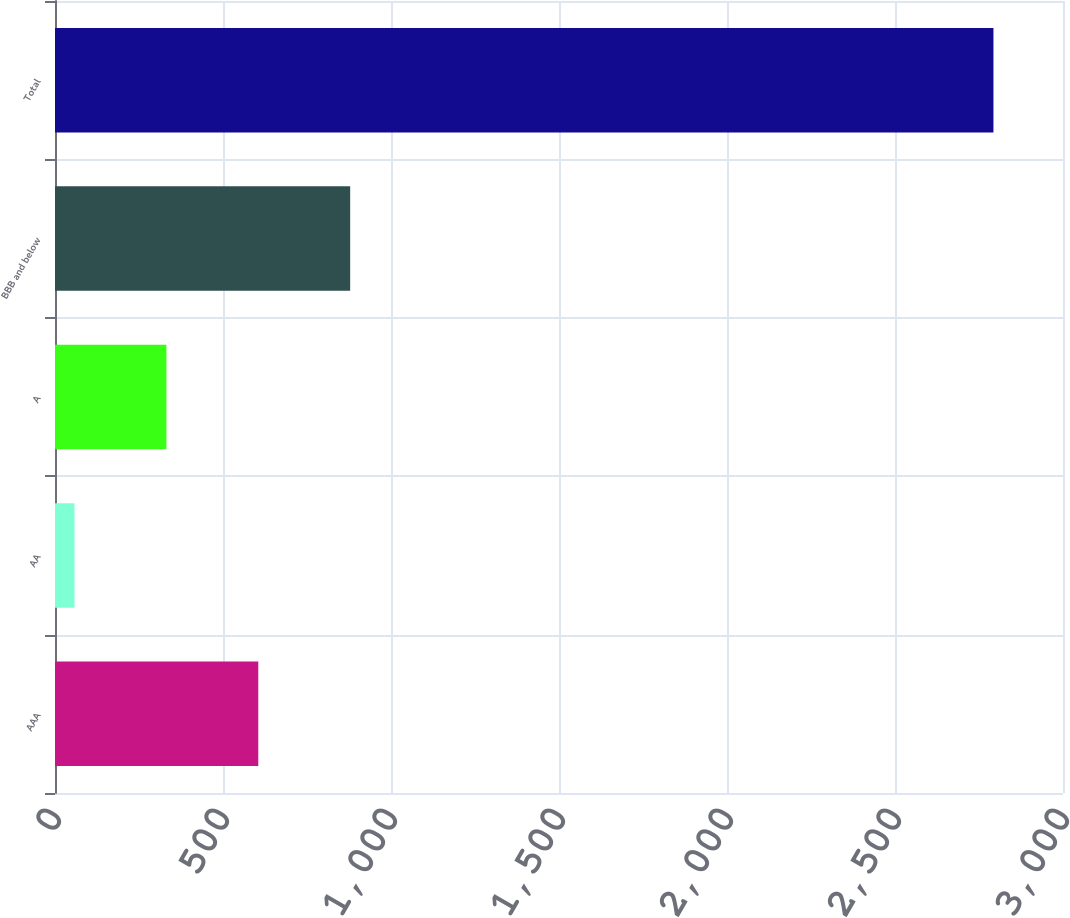Convert chart to OTSL. <chart><loc_0><loc_0><loc_500><loc_500><bar_chart><fcel>AAA<fcel>AA<fcel>A<fcel>BBB and below<fcel>Total<nl><fcel>605<fcel>58<fcel>331.5<fcel>878.5<fcel>2793<nl></chart> 